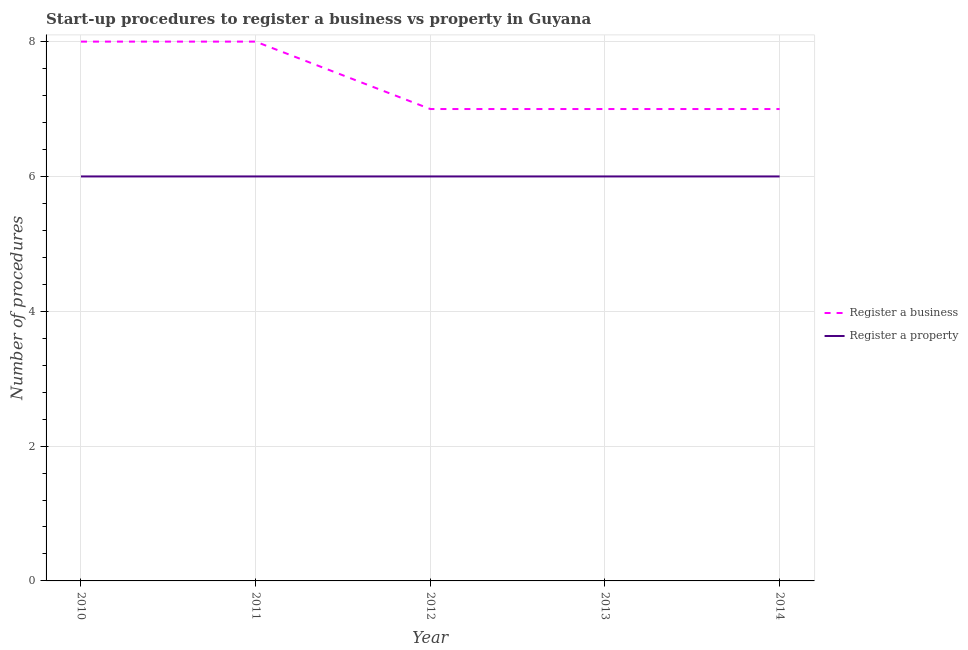What is the number of procedures to register a business in 2013?
Your answer should be very brief. 7. Across all years, what is the minimum number of procedures to register a business?
Ensure brevity in your answer.  7. In which year was the number of procedures to register a business minimum?
Ensure brevity in your answer.  2012. What is the total number of procedures to register a business in the graph?
Your response must be concise. 37. What is the difference between the number of procedures to register a business in 2010 and that in 2012?
Provide a short and direct response. 1. What is the difference between the number of procedures to register a property in 2011 and the number of procedures to register a business in 2014?
Your response must be concise. -1. In the year 2011, what is the difference between the number of procedures to register a property and number of procedures to register a business?
Make the answer very short. -2. In how many years, is the number of procedures to register a business greater than 2.4?
Your answer should be very brief. 5. What is the ratio of the number of procedures to register a property in 2012 to that in 2014?
Ensure brevity in your answer.  1. What is the difference between the highest and the second highest number of procedures to register a business?
Keep it short and to the point. 0. In how many years, is the number of procedures to register a property greater than the average number of procedures to register a property taken over all years?
Provide a succinct answer. 0. Is the sum of the number of procedures to register a property in 2010 and 2013 greater than the maximum number of procedures to register a business across all years?
Keep it short and to the point. Yes. Does the number of procedures to register a business monotonically increase over the years?
Your answer should be compact. No. Does the graph contain any zero values?
Provide a short and direct response. No. Does the graph contain grids?
Your answer should be very brief. Yes. Where does the legend appear in the graph?
Your response must be concise. Center right. How are the legend labels stacked?
Provide a succinct answer. Vertical. What is the title of the graph?
Your response must be concise. Start-up procedures to register a business vs property in Guyana. Does "Domestic liabilities" appear as one of the legend labels in the graph?
Give a very brief answer. No. What is the label or title of the X-axis?
Your answer should be compact. Year. What is the label or title of the Y-axis?
Provide a succinct answer. Number of procedures. What is the Number of procedures in Register a business in 2010?
Make the answer very short. 8. What is the Number of procedures in Register a property in 2010?
Provide a succinct answer. 6. Across all years, what is the maximum Number of procedures in Register a property?
Provide a short and direct response. 6. Across all years, what is the minimum Number of procedures in Register a property?
Your answer should be very brief. 6. What is the difference between the Number of procedures of Register a business in 2010 and that in 2012?
Your answer should be very brief. 1. What is the difference between the Number of procedures of Register a property in 2010 and that in 2012?
Ensure brevity in your answer.  0. What is the difference between the Number of procedures of Register a property in 2010 and that in 2013?
Offer a terse response. 0. What is the difference between the Number of procedures in Register a property in 2010 and that in 2014?
Make the answer very short. 0. What is the difference between the Number of procedures in Register a business in 2011 and that in 2012?
Offer a very short reply. 1. What is the difference between the Number of procedures in Register a property in 2011 and that in 2012?
Offer a very short reply. 0. What is the difference between the Number of procedures of Register a business in 2011 and that in 2013?
Offer a very short reply. 1. What is the difference between the Number of procedures of Register a property in 2011 and that in 2014?
Provide a short and direct response. 0. What is the difference between the Number of procedures in Register a property in 2012 and that in 2013?
Provide a short and direct response. 0. What is the difference between the Number of procedures in Register a property in 2013 and that in 2014?
Give a very brief answer. 0. What is the difference between the Number of procedures in Register a business in 2011 and the Number of procedures in Register a property in 2014?
Your response must be concise. 2. What is the difference between the Number of procedures in Register a business in 2012 and the Number of procedures in Register a property in 2013?
Offer a very short reply. 1. What is the difference between the Number of procedures in Register a business in 2012 and the Number of procedures in Register a property in 2014?
Offer a very short reply. 1. In the year 2012, what is the difference between the Number of procedures of Register a business and Number of procedures of Register a property?
Your response must be concise. 1. In the year 2013, what is the difference between the Number of procedures in Register a business and Number of procedures in Register a property?
Provide a short and direct response. 1. In the year 2014, what is the difference between the Number of procedures in Register a business and Number of procedures in Register a property?
Give a very brief answer. 1. What is the ratio of the Number of procedures in Register a business in 2010 to that in 2012?
Provide a short and direct response. 1.14. What is the ratio of the Number of procedures in Register a property in 2010 to that in 2012?
Offer a very short reply. 1. What is the ratio of the Number of procedures in Register a business in 2010 to that in 2013?
Your answer should be very brief. 1.14. What is the ratio of the Number of procedures of Register a business in 2011 to that in 2012?
Offer a very short reply. 1.14. What is the ratio of the Number of procedures of Register a property in 2011 to that in 2012?
Your answer should be very brief. 1. What is the ratio of the Number of procedures in Register a business in 2012 to that in 2014?
Your answer should be very brief. 1. What is the ratio of the Number of procedures of Register a business in 2013 to that in 2014?
Give a very brief answer. 1. What is the ratio of the Number of procedures of Register a property in 2013 to that in 2014?
Your answer should be very brief. 1. What is the difference between the highest and the lowest Number of procedures of Register a business?
Your response must be concise. 1. What is the difference between the highest and the lowest Number of procedures of Register a property?
Ensure brevity in your answer.  0. 